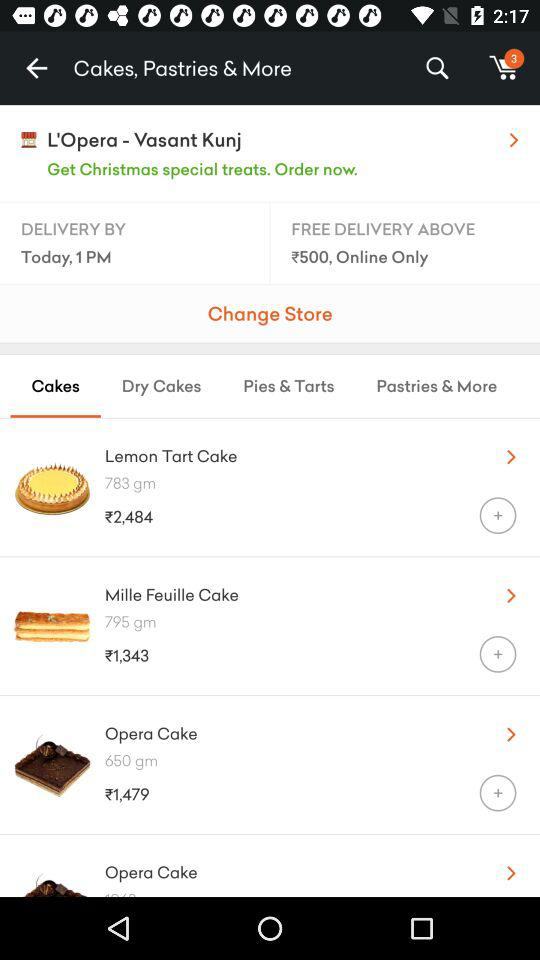What is the delivery address?
When the provided information is insufficient, respond with <no answer>. <no answer> 